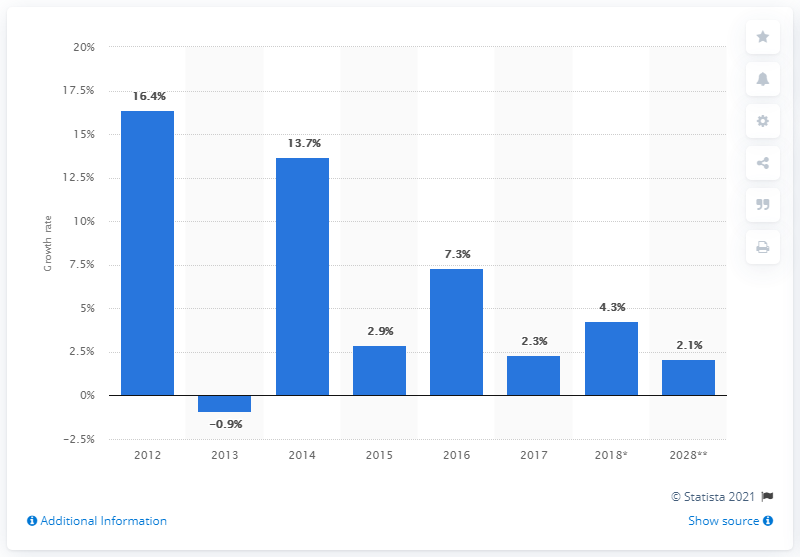What might explain the recovery in growth rate in 2018 after several years of decline? Recovery in growth rates, like the one seen in 2018, can be attributed to a variety of factors such as the introduction of economic stimulus, the recovery of key industries, improvements in trade relations, or other favorable economic conditions. Each of these has the potential to contribute to an economic rebound after a period of slower growth or decline. 